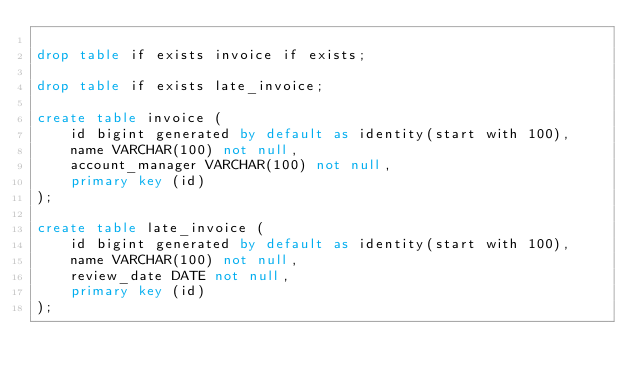Convert code to text. <code><loc_0><loc_0><loc_500><loc_500><_SQL_>
drop table if exists invoice if exists;

drop table if exists late_invoice;

create table invoice (
    id bigint generated by default as identity(start with 100),
    name VARCHAR(100) not null,
    account_manager VARCHAR(100) not null,
    primary key (id)
);

create table late_invoice (
    id bigint generated by default as identity(start with 100),
    name VARCHAR(100) not null,
    review_date DATE not null,
    primary key (id)
);
</code> 